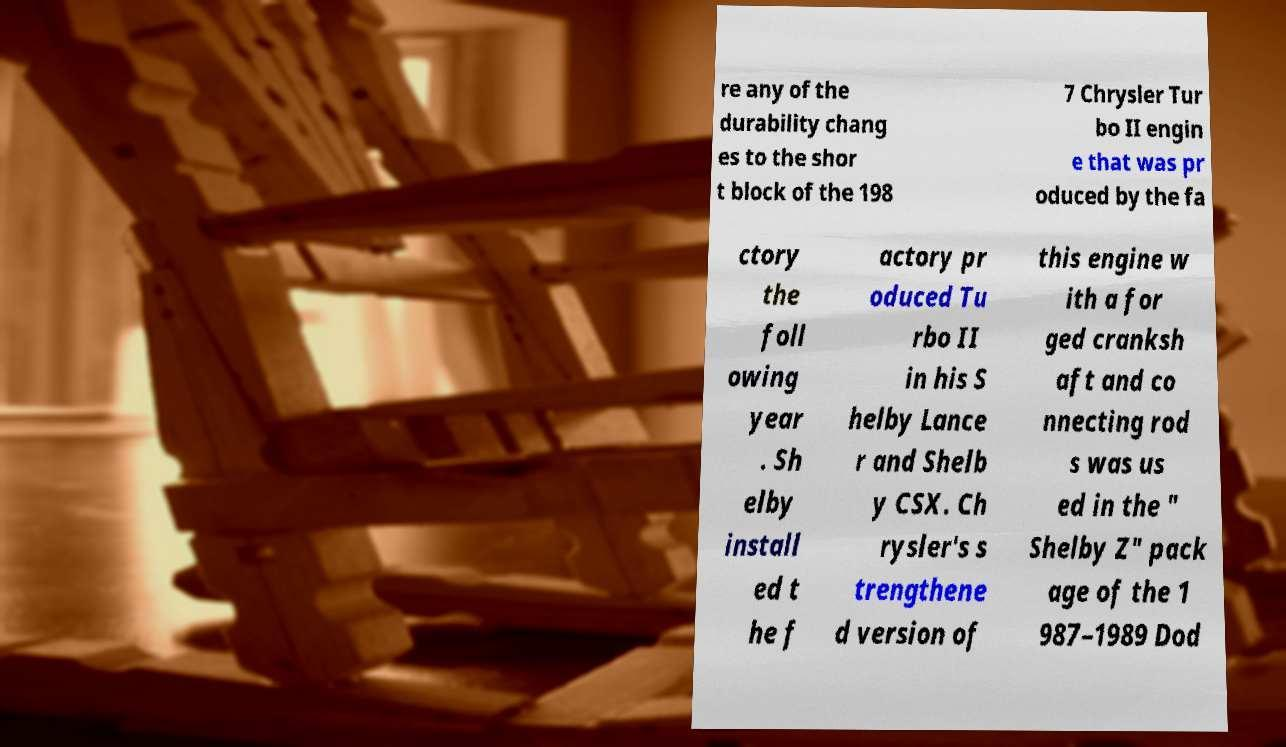Could you assist in decoding the text presented in this image and type it out clearly? re any of the durability chang es to the shor t block of the 198 7 Chrysler Tur bo II engin e that was pr oduced by the fa ctory the foll owing year . Sh elby install ed t he f actory pr oduced Tu rbo II in his S helby Lance r and Shelb y CSX. Ch rysler's s trengthene d version of this engine w ith a for ged cranksh aft and co nnecting rod s was us ed in the " Shelby Z" pack age of the 1 987–1989 Dod 